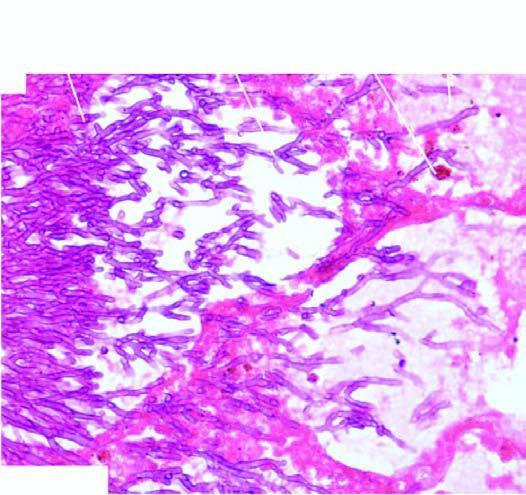what are best identified with a special stain for fungi, gomory 's methenamine silver gms?
Answer the question using a single word or phrase. Apergillus flavus 